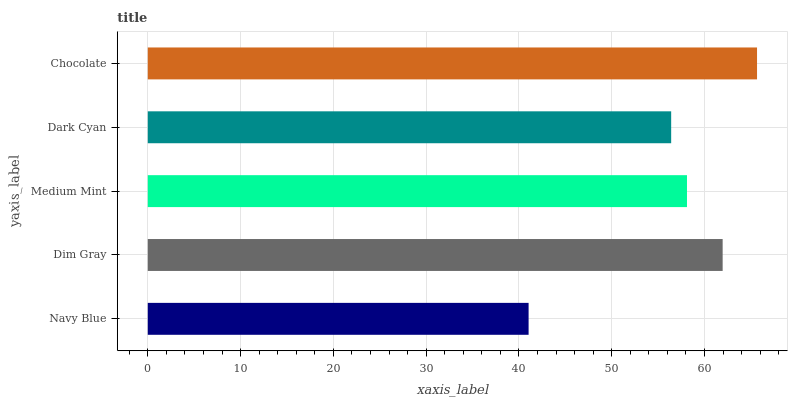Is Navy Blue the minimum?
Answer yes or no. Yes. Is Chocolate the maximum?
Answer yes or no. Yes. Is Dim Gray the minimum?
Answer yes or no. No. Is Dim Gray the maximum?
Answer yes or no. No. Is Dim Gray greater than Navy Blue?
Answer yes or no. Yes. Is Navy Blue less than Dim Gray?
Answer yes or no. Yes. Is Navy Blue greater than Dim Gray?
Answer yes or no. No. Is Dim Gray less than Navy Blue?
Answer yes or no. No. Is Medium Mint the high median?
Answer yes or no. Yes. Is Medium Mint the low median?
Answer yes or no. Yes. Is Chocolate the high median?
Answer yes or no. No. Is Dim Gray the low median?
Answer yes or no. No. 